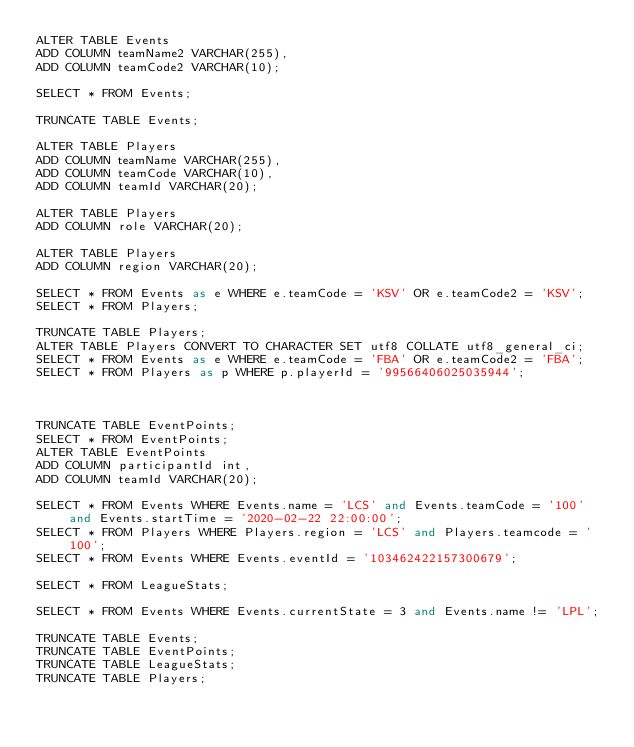<code> <loc_0><loc_0><loc_500><loc_500><_SQL_>ALTER TABLE Events
ADD COLUMN teamName2 VARCHAR(255),
ADD COLUMN teamCode2 VARCHAR(10);

SELECT * FROM Events;

TRUNCATE TABLE Events;

ALTER TABLE Players
ADD COLUMN teamName VARCHAR(255),
ADD COLUMN teamCode VARCHAR(10),
ADD COLUMN teamId VARCHAR(20);

ALTER TABLE Players
ADD COLUMN role VARCHAR(20);

ALTER TABLE Players
ADD COLUMN region VARCHAR(20);

SELECT * FROM Events as e WHERE e.teamCode = 'KSV' OR e.teamCode2 = 'KSV';
SELECT * FROM Players;

TRUNCATE TABLE Players;
ALTER TABLE Players CONVERT TO CHARACTER SET utf8 COLLATE utf8_general_ci;
SELECT * FROM Events as e WHERE e.teamCode = 'FBA' OR e.teamCode2 = 'FBA';
SELECT * FROM Players as p WHERE p.playerId = '99566406025035944';



TRUNCATE TABLE EventPoints;
SELECT * FROM EventPoints;
ALTER TABLE EventPoints
ADD COLUMN participantId int,
ADD COLUMN teamId VARCHAR(20);

SELECT * FROM Events WHERE Events.name = 'LCS' and Events.teamCode = '100' and Events.startTime = '2020-02-22 22:00:00';
SELECT * FROM Players WHERE Players.region = 'LCS' and Players.teamcode = '100';
SELECT * FROM Events WHERE Events.eventId = '103462422157300679';

SELECT * FROM LeagueStats;

SELECT * FROM Events WHERE Events.currentState = 3 and Events.name != 'LPL';

TRUNCATE TABLE Events;
TRUNCATE TABLE EventPoints;
TRUNCATE TABLE LeagueStats;
TRUNCATE TABLE Players;</code> 